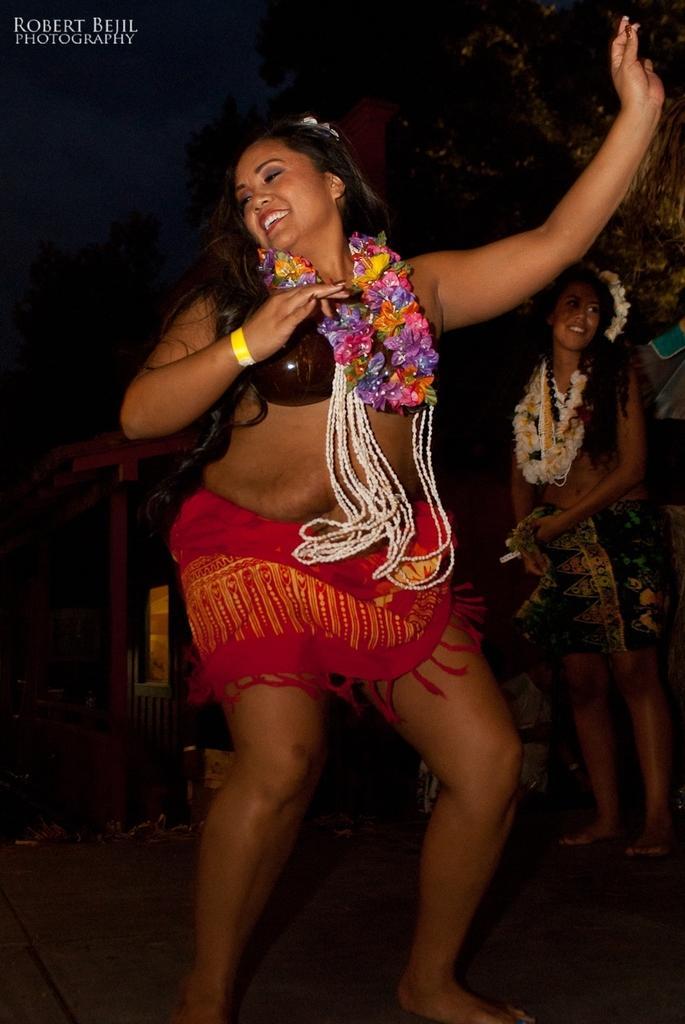Could you give a brief overview of what you see in this image? In this picture we can see the group of people and in the foreground we can see a woman wearing garland and seems to be dancing and in the background we can see the sky, trees and a woman wearing garlands, smiling and standing on the ground and we can see some other items in the background. In the top left corner we can see the text on the image. 